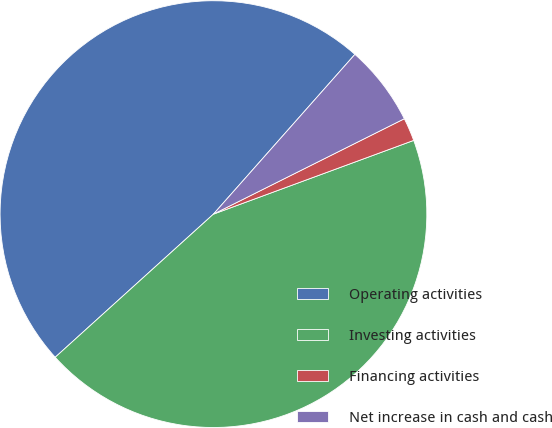Convert chart to OTSL. <chart><loc_0><loc_0><loc_500><loc_500><pie_chart><fcel>Operating activities<fcel>Investing activities<fcel>Financing activities<fcel>Net increase in cash and cash<nl><fcel>48.24%<fcel>43.91%<fcel>1.76%<fcel>6.09%<nl></chart> 